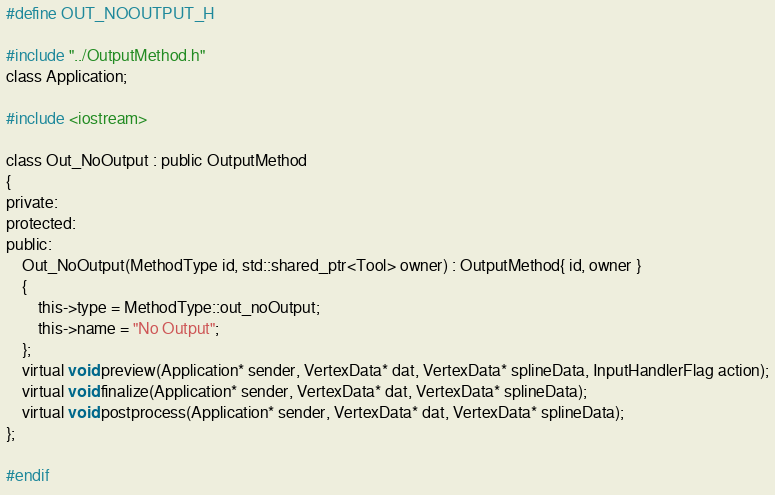<code> <loc_0><loc_0><loc_500><loc_500><_C_>#define OUT_NOOUTPUT_H

#include "../OutputMethod.h"
class Application;

#include <iostream>

class Out_NoOutput : public OutputMethod
{
private:
protected:
public:
	Out_NoOutput(MethodType id, std::shared_ptr<Tool> owner) : OutputMethod{ id, owner }
	{ 
		this->type = MethodType::out_noOutput;
		this->name = "No Output"; 
	};
	virtual void preview(Application* sender, VertexData* dat, VertexData* splineData, InputHandlerFlag action);
	virtual void finalize(Application* sender, VertexData* dat, VertexData* splineData);
	virtual void postprocess(Application* sender, VertexData* dat, VertexData* splineData);
};

#endif</code> 